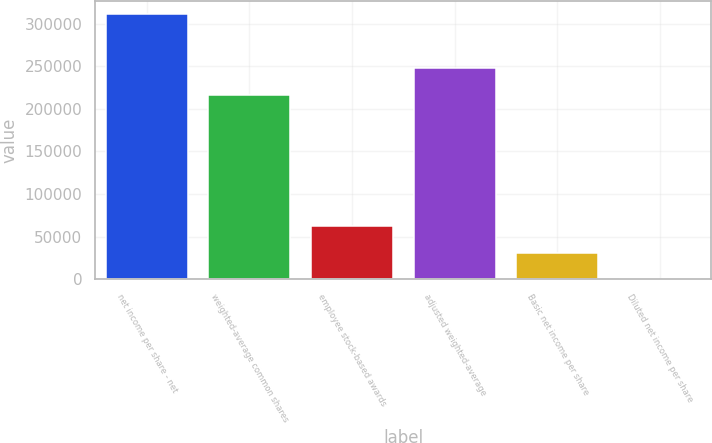Convert chart to OTSL. <chart><loc_0><loc_0><loc_500><loc_500><bar_chart><fcel>net income per share - net<fcel>weighted-average common shares<fcel>employee stock-based awards<fcel>adjusted weighted-average<fcel>Basic net income per share<fcel>Diluted net income per share<nl><fcel>311219<fcel>216294<fcel>62244.9<fcel>247416<fcel>31123.2<fcel>1.43<nl></chart> 